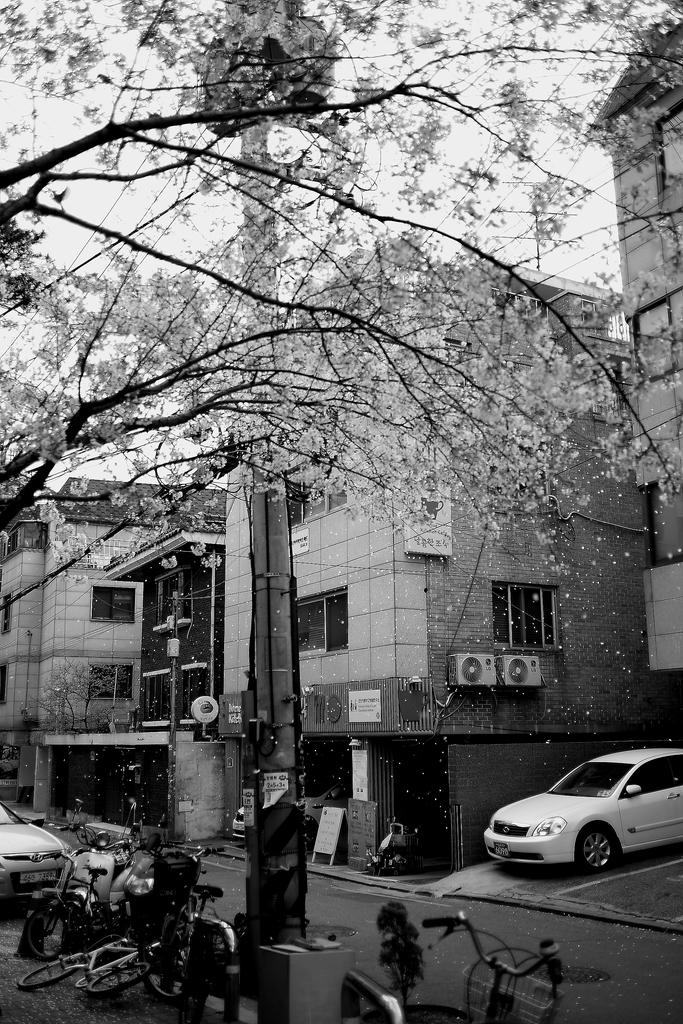What types of transportation can be seen on the road in the image? There are vehicles and bicycles on the road in the image. What structures are visible in the image? There are buildings visible in the image. What architectural features can be seen on the buildings? Windows are visible on the buildings in the image. What type of vegetation is present in the image? There are trees visible in the image. What other objects can be seen in the image? There is a pole visible in the image. What is the color scheme of the image? The image is in black and white. What type of milk is being distributed from the pole in the image? There is no milk or distribution activity present in the image; it only features vehicles, bicycles, buildings, windows, trees, and a pole. 